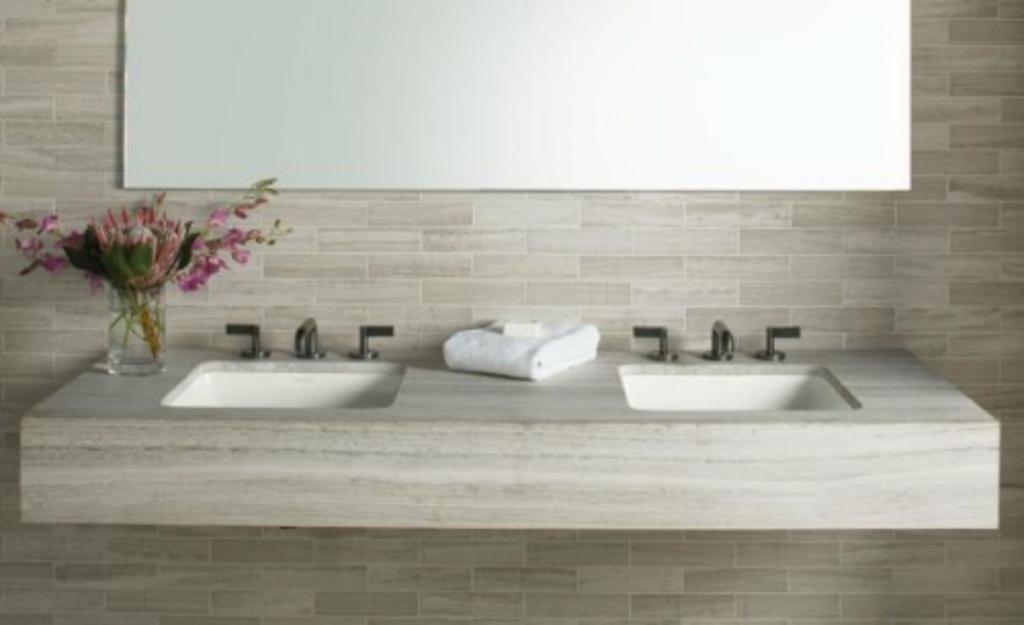Can you describe this image briefly? In the foreground of the picture there are taps, sinks, towel, flower vase and wall. 